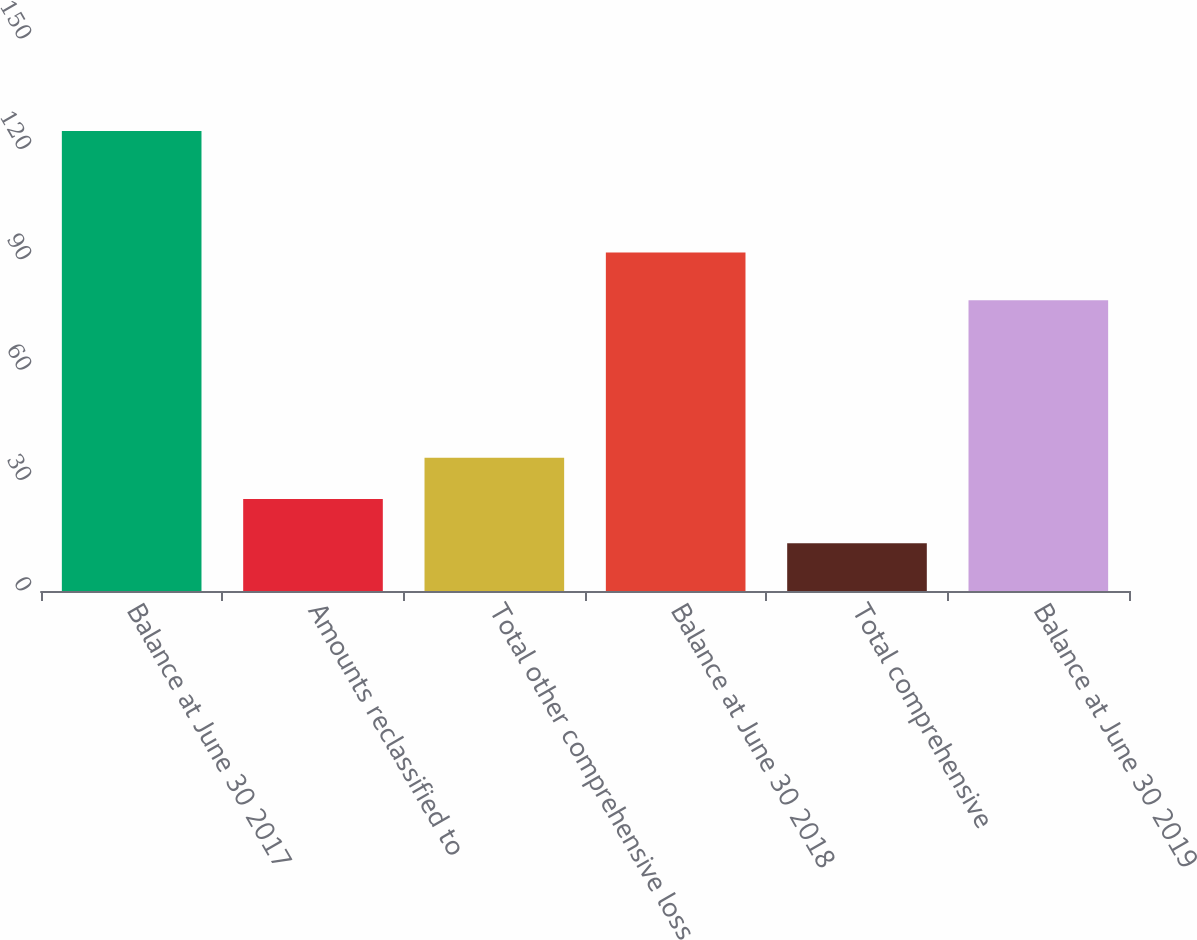<chart> <loc_0><loc_0><loc_500><loc_500><bar_chart><fcel>Balance at June 30 2017<fcel>Amounts reclassified to<fcel>Total other comprehensive loss<fcel>Balance at June 30 2018<fcel>Total comprehensive<fcel>Balance at June 30 2019<nl><fcel>125<fcel>25<fcel>36.2<fcel>92<fcel>13<fcel>79<nl></chart> 